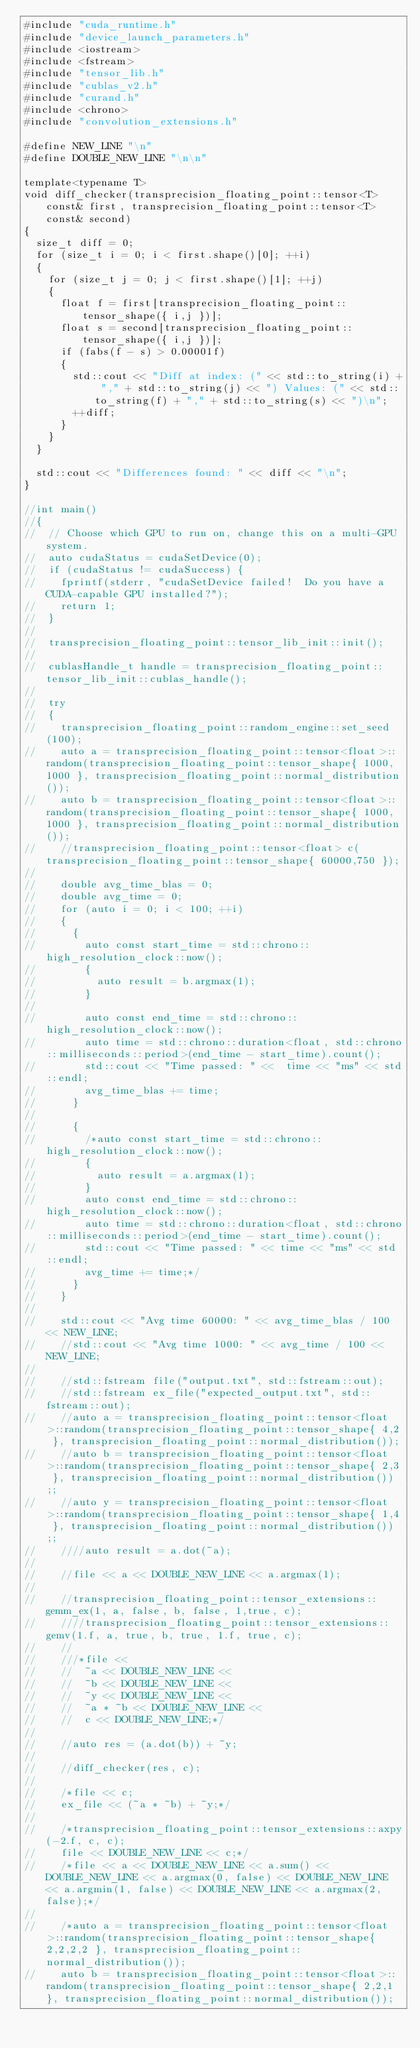<code> <loc_0><loc_0><loc_500><loc_500><_Cuda_>#include "cuda_runtime.h"
#include "device_launch_parameters.h"
#include <iostream>
#include <fstream>
#include "tensor_lib.h"
#include "cublas_v2.h"
#include "curand.h"
#include <chrono>
#include "convolution_extensions.h"

#define NEW_LINE "\n"
#define DOUBLE_NEW_LINE "\n\n"

template<typename T>
void diff_checker(transprecision_floating_point::tensor<T> const& first, transprecision_floating_point::tensor<T> const& second)
{
	size_t diff = 0;
	for (size_t i = 0; i < first.shape()[0]; ++i)
	{
		for (size_t j = 0; j < first.shape()[1]; ++j)
		{
			float f = first[transprecision_floating_point::tensor_shape({ i,j })];
			float s = second[transprecision_floating_point::tensor_shape({ i,j })];
			if (fabs(f - s) > 0.00001f)
			{
				std::cout << "Diff at index: (" << std::to_string(i) + "," + std::to_string(j) << ") Values: (" << std::to_string(f) + "," + std::to_string(s) << ")\n";
				++diff;
			}
		}
	}

	std::cout << "Differences found: " << diff << "\n";
}

//int main()
//{
//	// Choose which GPU to run on, change this on a multi-GPU system.
//	auto cudaStatus = cudaSetDevice(0);
//	if (cudaStatus != cudaSuccess) {
//		fprintf(stderr, "cudaSetDevice failed!  Do you have a CUDA-capable GPU installed?");
//		return 1;
//	}
//
//	transprecision_floating_point::tensor_lib_init::init();
//
//	cublasHandle_t handle = transprecision_floating_point::tensor_lib_init::cublas_handle();
//
//	try
//	{
//		transprecision_floating_point::random_engine::set_seed(100);
//		auto a = transprecision_floating_point::tensor<float>::random(transprecision_floating_point::tensor_shape{ 1000, 1000 }, transprecision_floating_point::normal_distribution());
//		auto b = transprecision_floating_point::tensor<float>::random(transprecision_floating_point::tensor_shape{ 1000, 1000 }, transprecision_floating_point::normal_distribution());
//		//transprecision_floating_point::tensor<float> c(transprecision_floating_point::tensor_shape{ 60000,750 });
//
//		double avg_time_blas = 0;
//		double avg_time = 0;
//		for (auto i = 0; i < 100; ++i)
//		{
//			{
//				auto const start_time = std::chrono::high_resolution_clock::now();
//				{
//					auto result = b.argmax(1);
//				}
//
//				auto const end_time = std::chrono::high_resolution_clock::now();
//				auto time = std::chrono::duration<float, std::chrono::milliseconds::period>(end_time - start_time).count();
//				std::cout << "Time passed: " <<  time << "ms" << std::endl;
//				avg_time_blas += time;
//			}
//
//			{
//				/*auto const start_time = std::chrono::high_resolution_clock::now();
//				{
//					auto result = a.argmax(1);
//				}
//				auto const end_time = std::chrono::high_resolution_clock::now();
//				auto time = std::chrono::duration<float, std::chrono::milliseconds::period>(end_time - start_time).count();
//				std::cout << "Time passed: " << time << "ms" << std::endl;
//				avg_time += time;*/
//			}
//		}
//
//		std::cout << "Avg time 60000: " << avg_time_blas / 100 << NEW_LINE;
//		//std::cout << "Avg time 1000: " << avg_time / 100 << NEW_LINE;
//
//		//std::fstream file("output.txt", std::fstream::out);
//		//std::fstream ex_file("expected_output.txt", std::fstream::out);
//		//auto a = transprecision_floating_point::tensor<float>::random(transprecision_floating_point::tensor_shape{ 4,2 }, transprecision_floating_point::normal_distribution());
//		//auto b = transprecision_floating_point::tensor<float>::random(transprecision_floating_point::tensor_shape{ 2,3 }, transprecision_floating_point::normal_distribution());;
//		//auto y = transprecision_floating_point::tensor<float>::random(transprecision_floating_point::tensor_shape{ 1,4 }, transprecision_floating_point::normal_distribution());;
//		////auto result = a.dot(~a);
//
//		//file << a << DOUBLE_NEW_LINE << a.argmax(1);
//
//		//transprecision_floating_point::tensor_extensions::gemm_ex(1, a, false, b, false, 1,true, c);
//		////transprecision_floating_point::tensor_extensions::gemv(1.f, a, true, b, true, 1.f, true, c);
//		//
//		///*file <<
//		//	~a << DOUBLE_NEW_LINE <<
//		//	~b << DOUBLE_NEW_LINE <<
//		//	~y << DOUBLE_NEW_LINE <<
//		//	~a * ~b << DOUBLE_NEW_LINE <<
//		//	c << DOUBLE_NEW_LINE;*/
//
//		//auto res = (a.dot(b)) + ~y;
//
//		//diff_checker(res, c);
//
//		/*file << c;
//		ex_file << (~a * ~b) + ~y;*/
//
//		/*transprecision_floating_point::tensor_extensions::axpy(-2.f, c, c);
//		file << DOUBLE_NEW_LINE << c;*/
//		/*file << a << DOUBLE_NEW_LINE << a.sum() << DOUBLE_NEW_LINE << a.argmax(0, false) << DOUBLE_NEW_LINE << a.argmin(1, false) << DOUBLE_NEW_LINE << a.argmax(2, false);*/
//
//		/*auto a = transprecision_floating_point::tensor<float>::random(transprecision_floating_point::tensor_shape{ 2,2,2,2 }, transprecision_floating_point::normal_distribution());
//		auto b = transprecision_floating_point::tensor<float>::random(transprecision_floating_point::tensor_shape{ 2,2,1 }, transprecision_floating_point::normal_distribution());</code> 